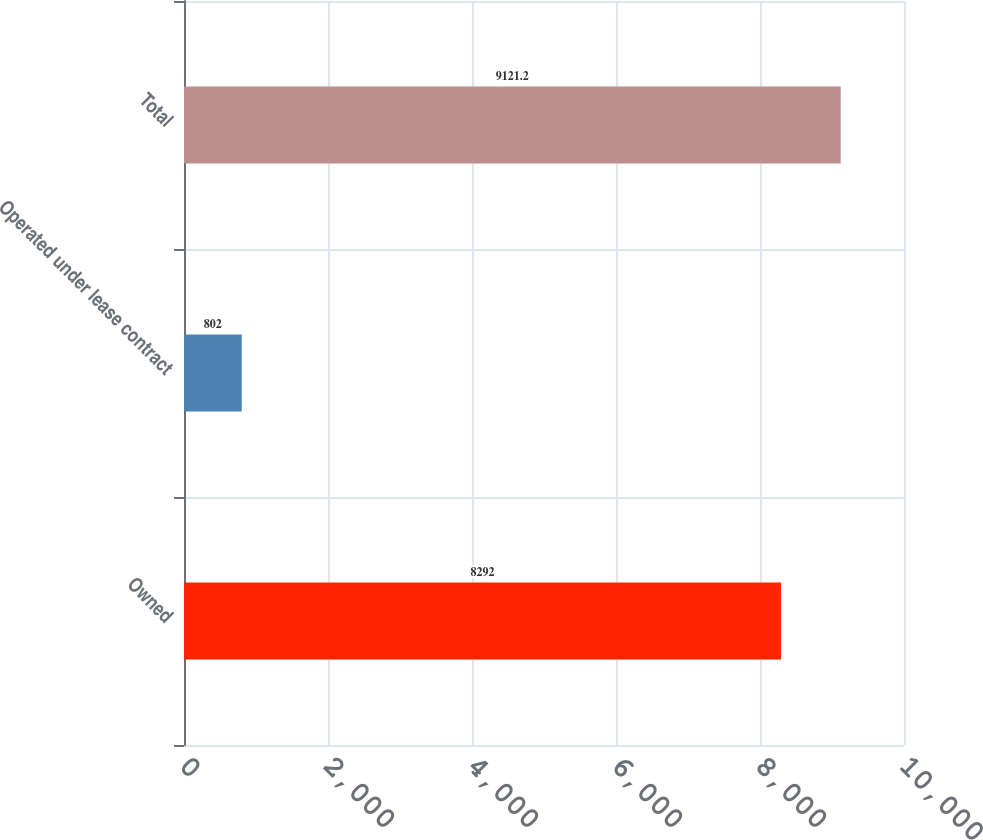<chart> <loc_0><loc_0><loc_500><loc_500><bar_chart><fcel>Owned<fcel>Operated under lease contract<fcel>Total<nl><fcel>8292<fcel>802<fcel>9121.2<nl></chart> 